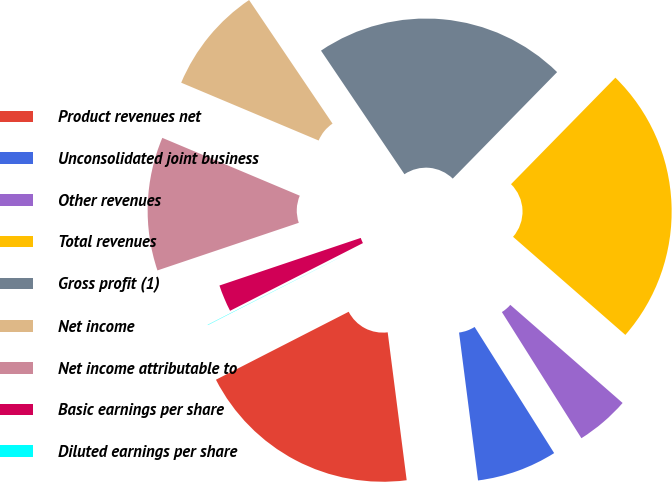<chart> <loc_0><loc_0><loc_500><loc_500><pie_chart><fcel>Product revenues net<fcel>Unconsolidated joint business<fcel>Other revenues<fcel>Total revenues<fcel>Gross profit (1)<fcel>Net income<fcel>Net income attributable to<fcel>Basic earnings per share<fcel>Diluted earnings per share<nl><fcel>19.5%<fcel>6.92%<fcel>4.62%<fcel>24.09%<fcel>21.79%<fcel>9.21%<fcel>11.51%<fcel>2.33%<fcel>0.03%<nl></chart> 